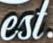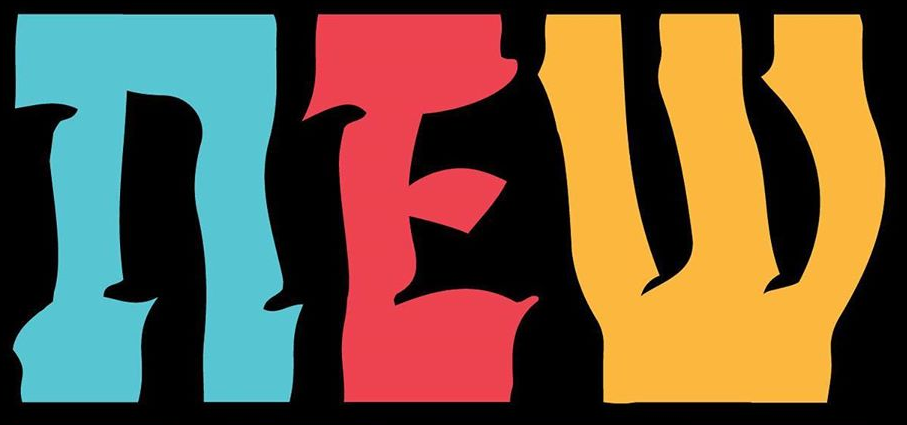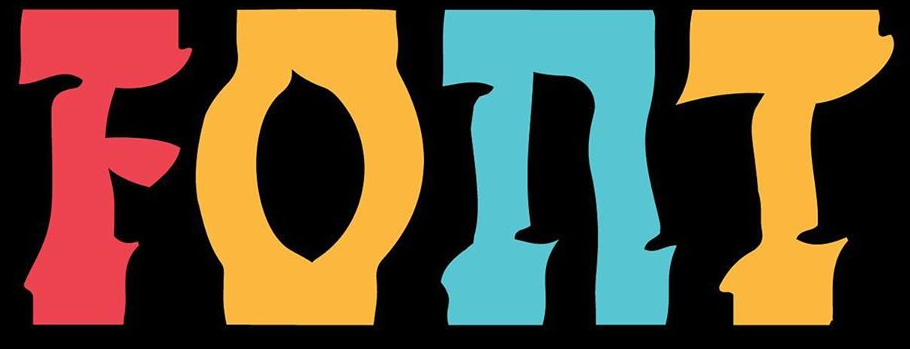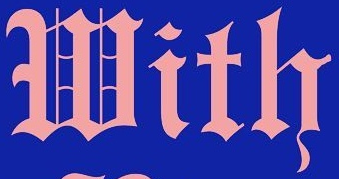What text appears in these images from left to right, separated by a semicolon? est; nEW; FOnT; With 